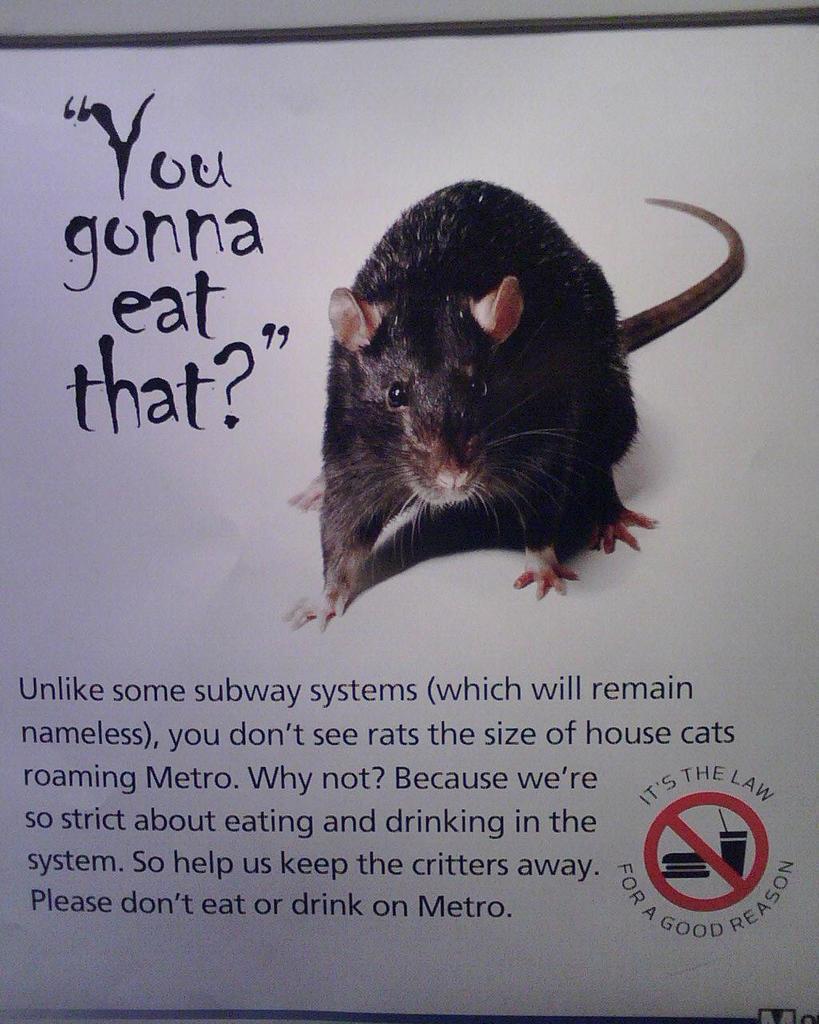Could you give a brief overview of what you see in this image? In the picture I can see a photo of a rat and something written on a white color board. 